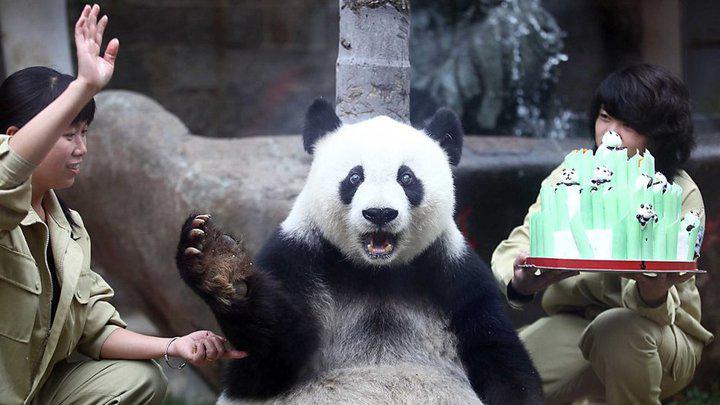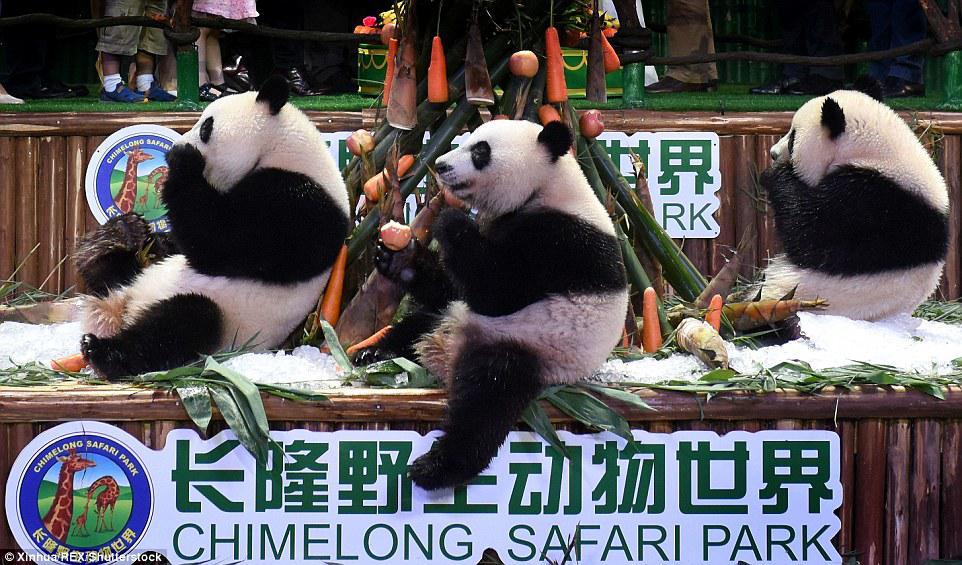The first image is the image on the left, the second image is the image on the right. Evaluate the accuracy of this statement regarding the images: "An image shows at least one person in protective gear behind a panda, grasping it". Is it true? Answer yes or no. No. The first image is the image on the left, the second image is the image on the right. Evaluate the accuracy of this statement regarding the images: "People are interacting with a panda in the image on the left.". Is it true? Answer yes or no. Yes. 